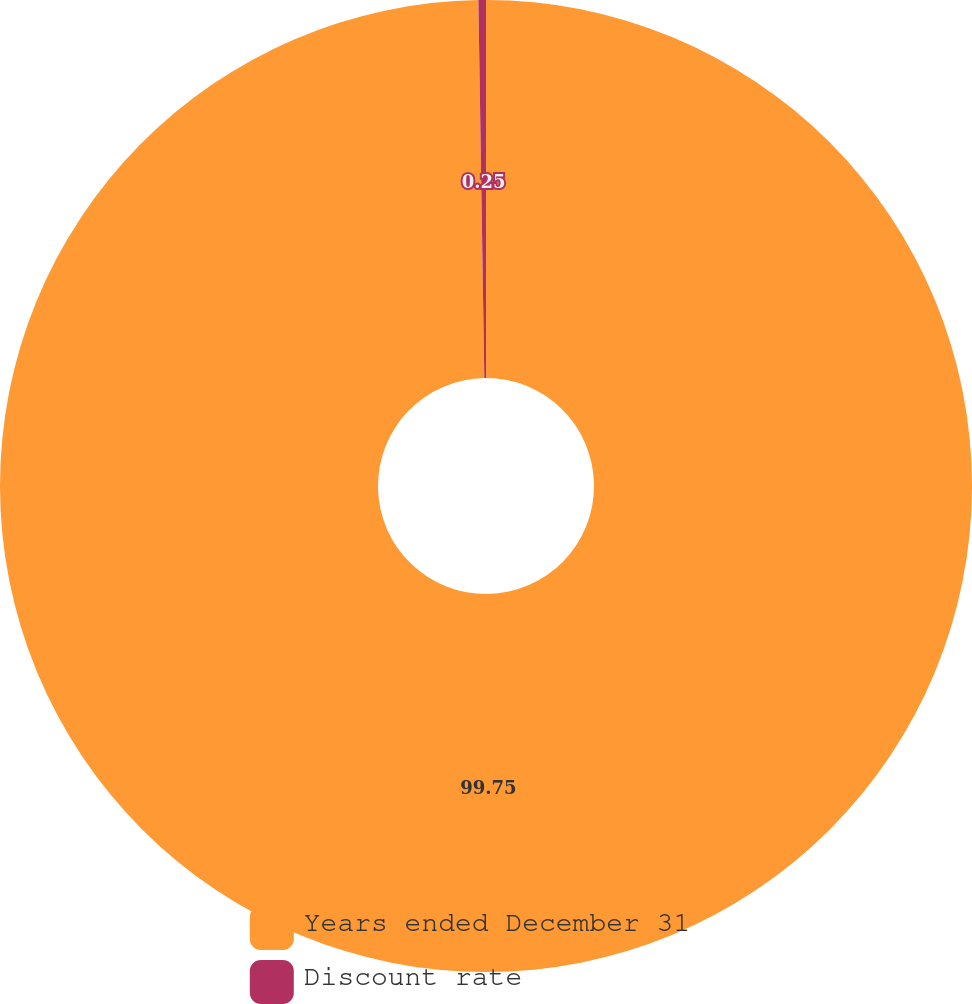Convert chart. <chart><loc_0><loc_0><loc_500><loc_500><pie_chart><fcel>Years ended December 31<fcel>Discount rate<nl><fcel>99.75%<fcel>0.25%<nl></chart> 